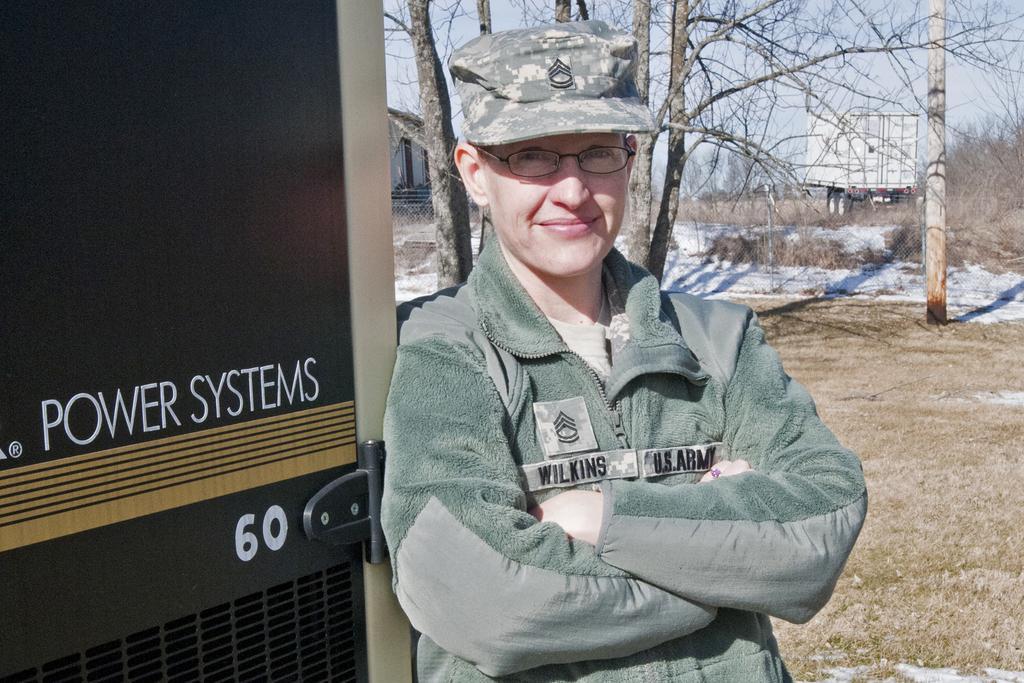Could you give a brief overview of what you see in this image? In the image there is a person wearing jacket and camouflage cap standing, in the back there are dried trees on the land with a truck carriage in the background, on the left side it seems to be generator. 